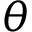Convert formula to latex. <formula><loc_0><loc_0><loc_500><loc_500>\theta</formula> 